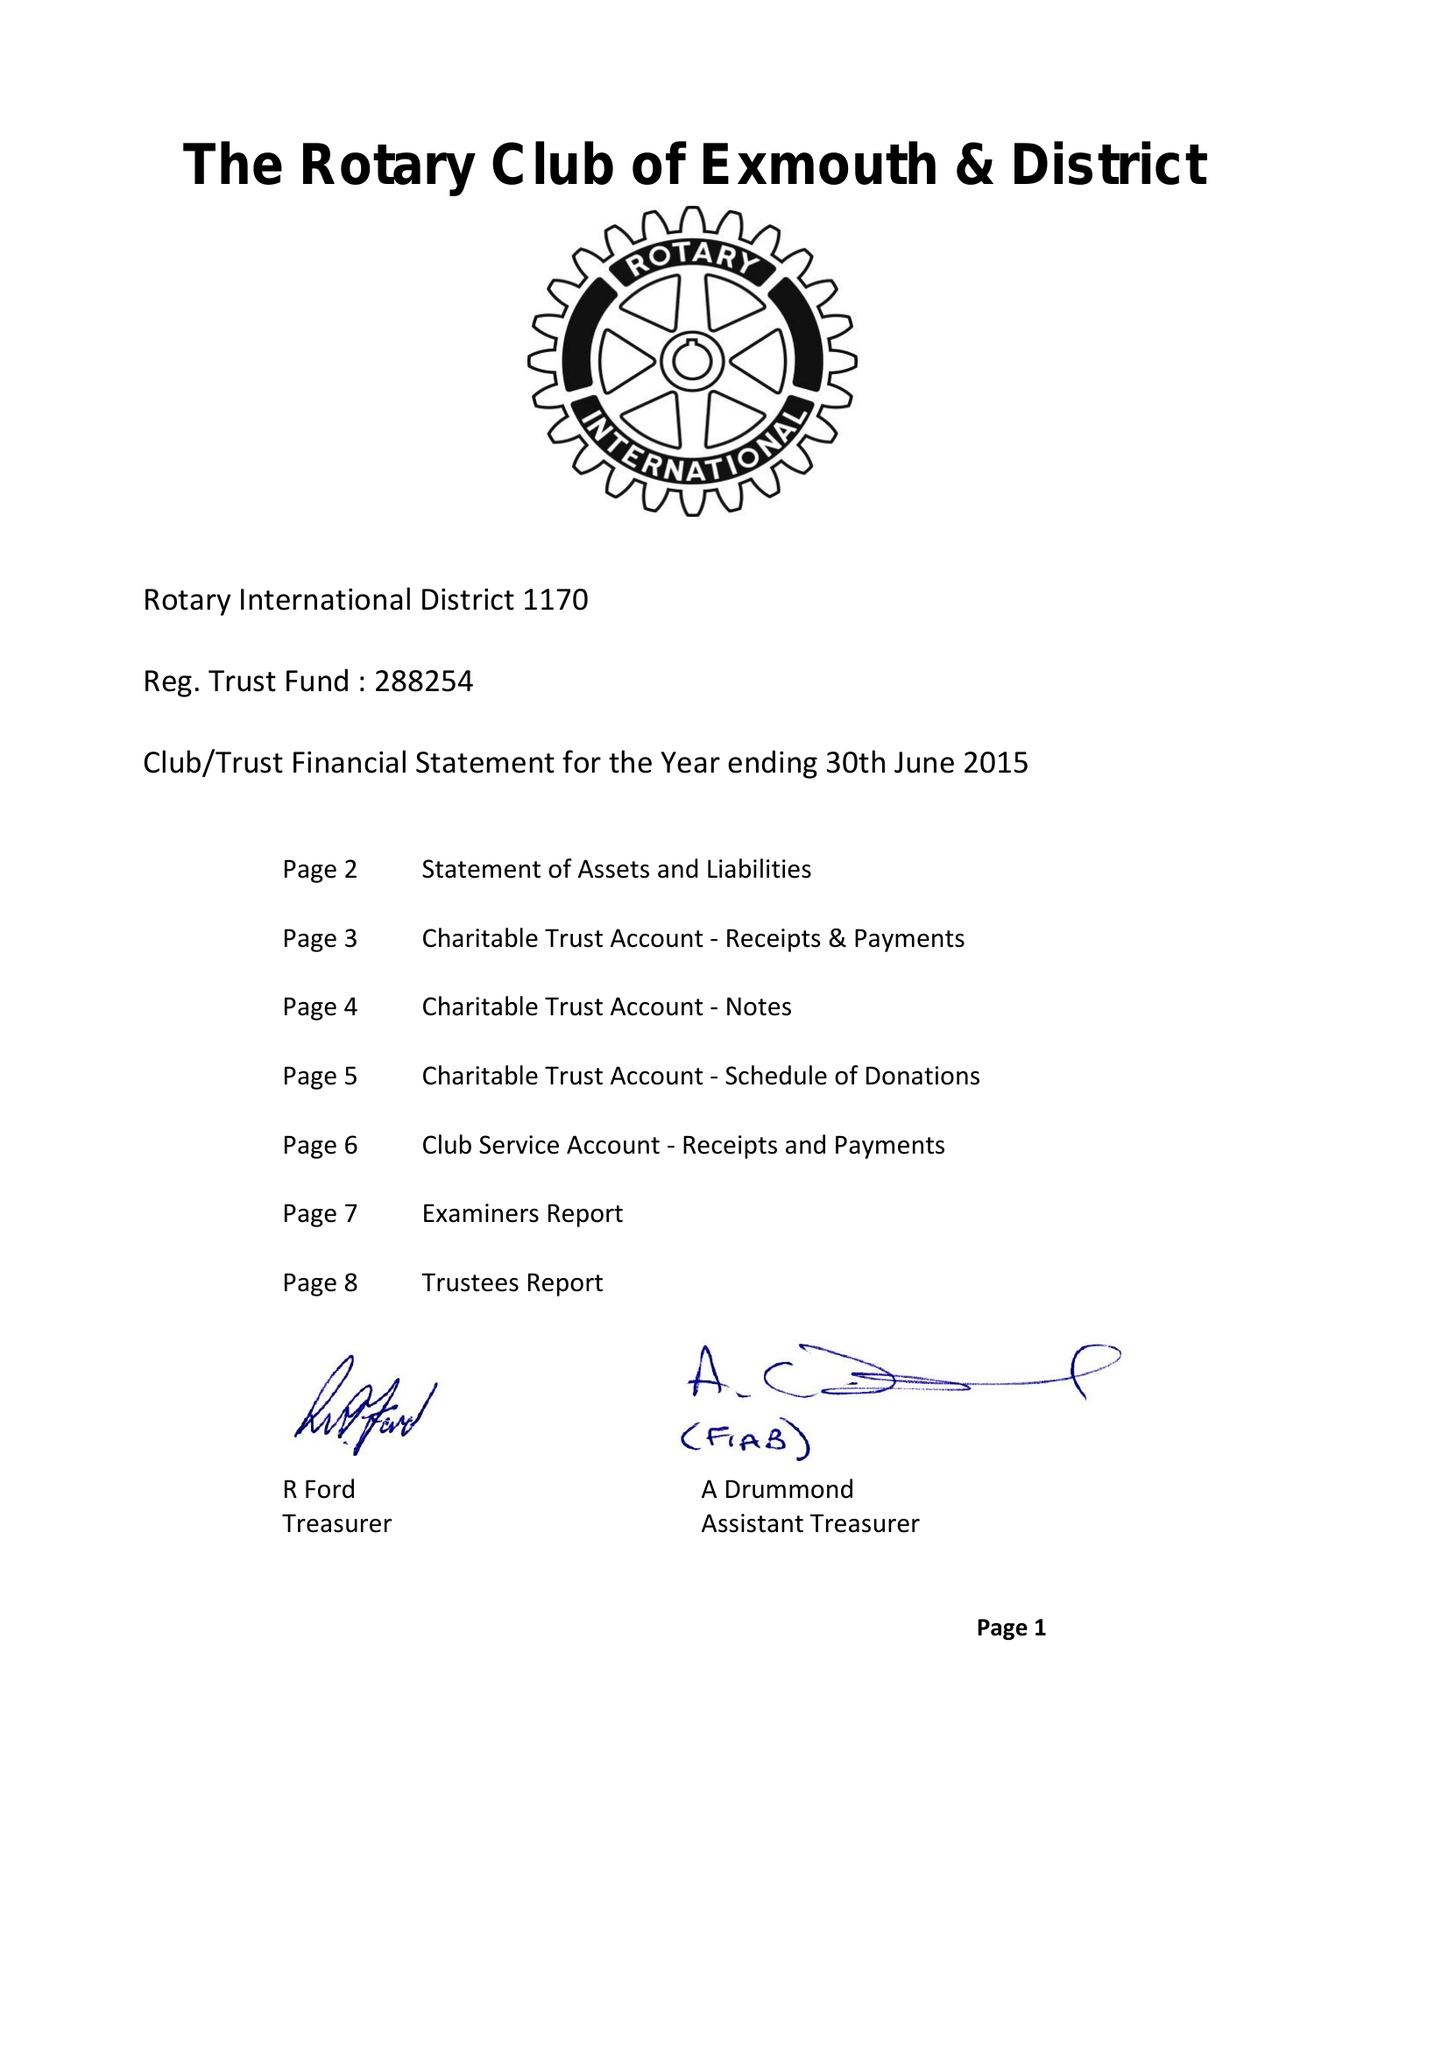What is the value for the report_date?
Answer the question using a single word or phrase. 2015-06-30 